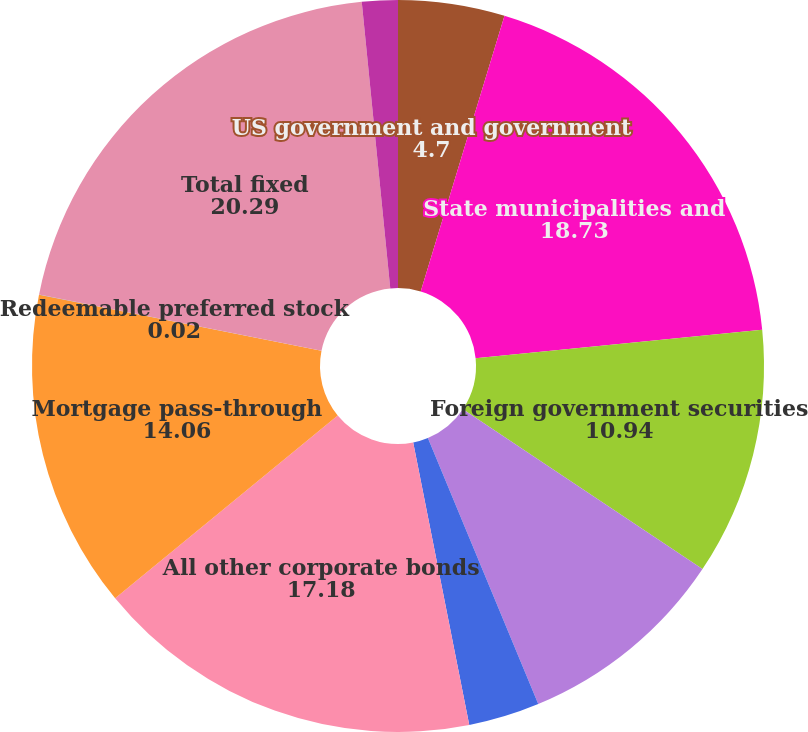Convert chart. <chart><loc_0><loc_0><loc_500><loc_500><pie_chart><fcel>US government and government<fcel>State municipalities and<fcel>Foreign government securities<fcel>Foreign corporate securities<fcel>Public utilities<fcel>All other corporate bonds<fcel>Mortgage pass-through<fcel>Redeemable preferred stock<fcel>Total fixed<fcel>Equity securities - available<nl><fcel>4.7%<fcel>18.73%<fcel>10.94%<fcel>9.38%<fcel>3.14%<fcel>17.18%<fcel>14.06%<fcel>0.02%<fcel>20.29%<fcel>1.58%<nl></chart> 